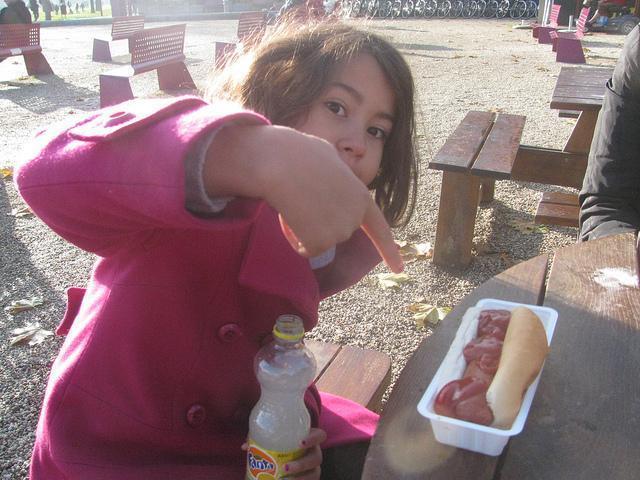How many people are in the picture?
Give a very brief answer. 2. How many benches are there?
Give a very brief answer. 3. How many dining tables are there?
Give a very brief answer. 2. How many elephants are in the picture?
Give a very brief answer. 0. 